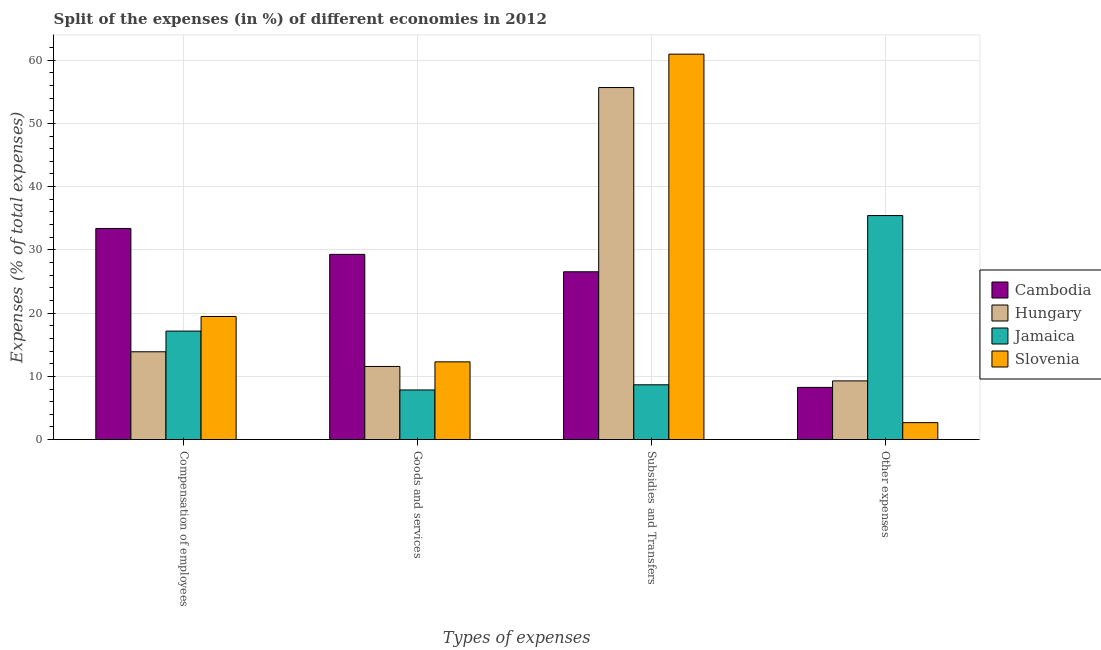How many different coloured bars are there?
Your answer should be very brief. 4. How many groups of bars are there?
Provide a short and direct response. 4. Are the number of bars per tick equal to the number of legend labels?
Your answer should be very brief. Yes. What is the label of the 3rd group of bars from the left?
Give a very brief answer. Subsidies and Transfers. What is the percentage of amount spent on compensation of employees in Slovenia?
Offer a terse response. 19.47. Across all countries, what is the maximum percentage of amount spent on other expenses?
Your response must be concise. 35.42. Across all countries, what is the minimum percentage of amount spent on goods and services?
Your answer should be compact. 7.85. In which country was the percentage of amount spent on subsidies maximum?
Your answer should be compact. Slovenia. In which country was the percentage of amount spent on other expenses minimum?
Keep it short and to the point. Slovenia. What is the total percentage of amount spent on other expenses in the graph?
Provide a short and direct response. 55.64. What is the difference between the percentage of amount spent on subsidies in Slovenia and that in Cambodia?
Your response must be concise. 34.41. What is the difference between the percentage of amount spent on goods and services in Hungary and the percentage of amount spent on other expenses in Cambodia?
Provide a succinct answer. 3.31. What is the average percentage of amount spent on compensation of employees per country?
Ensure brevity in your answer.  20.97. What is the difference between the percentage of amount spent on subsidies and percentage of amount spent on other expenses in Cambodia?
Make the answer very short. 18.28. In how many countries, is the percentage of amount spent on goods and services greater than 2 %?
Make the answer very short. 4. What is the ratio of the percentage of amount spent on goods and services in Jamaica to that in Cambodia?
Ensure brevity in your answer.  0.27. Is the percentage of amount spent on subsidies in Jamaica less than that in Cambodia?
Provide a succinct answer. Yes. Is the difference between the percentage of amount spent on goods and services in Cambodia and Slovenia greater than the difference between the percentage of amount spent on compensation of employees in Cambodia and Slovenia?
Offer a very short reply. Yes. What is the difference between the highest and the second highest percentage of amount spent on subsidies?
Offer a very short reply. 5.28. What is the difference between the highest and the lowest percentage of amount spent on other expenses?
Offer a very short reply. 32.74. In how many countries, is the percentage of amount spent on other expenses greater than the average percentage of amount spent on other expenses taken over all countries?
Give a very brief answer. 1. Is the sum of the percentage of amount spent on other expenses in Jamaica and Slovenia greater than the maximum percentage of amount spent on goods and services across all countries?
Your response must be concise. Yes. What does the 1st bar from the left in Goods and services represents?
Offer a terse response. Cambodia. What does the 2nd bar from the right in Compensation of employees represents?
Provide a succinct answer. Jamaica. How many bars are there?
Offer a terse response. 16. Are the values on the major ticks of Y-axis written in scientific E-notation?
Your answer should be compact. No. Does the graph contain any zero values?
Your answer should be very brief. No. Does the graph contain grids?
Offer a very short reply. Yes. How are the legend labels stacked?
Offer a very short reply. Vertical. What is the title of the graph?
Keep it short and to the point. Split of the expenses (in %) of different economies in 2012. What is the label or title of the X-axis?
Your answer should be very brief. Types of expenses. What is the label or title of the Y-axis?
Your answer should be very brief. Expenses (% of total expenses). What is the Expenses (% of total expenses) of Cambodia in Compensation of employees?
Your answer should be very brief. 33.38. What is the Expenses (% of total expenses) of Hungary in Compensation of employees?
Provide a short and direct response. 13.89. What is the Expenses (% of total expenses) of Jamaica in Compensation of employees?
Ensure brevity in your answer.  17.16. What is the Expenses (% of total expenses) in Slovenia in Compensation of employees?
Ensure brevity in your answer.  19.47. What is the Expenses (% of total expenses) of Cambodia in Goods and services?
Provide a succinct answer. 29.29. What is the Expenses (% of total expenses) in Hungary in Goods and services?
Provide a succinct answer. 11.57. What is the Expenses (% of total expenses) of Jamaica in Goods and services?
Make the answer very short. 7.85. What is the Expenses (% of total expenses) of Slovenia in Goods and services?
Offer a very short reply. 12.29. What is the Expenses (% of total expenses) in Cambodia in Subsidies and Transfers?
Ensure brevity in your answer.  26.54. What is the Expenses (% of total expenses) of Hungary in Subsidies and Transfers?
Make the answer very short. 55.66. What is the Expenses (% of total expenses) in Jamaica in Subsidies and Transfers?
Give a very brief answer. 8.67. What is the Expenses (% of total expenses) of Slovenia in Subsidies and Transfers?
Keep it short and to the point. 60.94. What is the Expenses (% of total expenses) in Cambodia in Other expenses?
Keep it short and to the point. 8.25. What is the Expenses (% of total expenses) in Hungary in Other expenses?
Offer a terse response. 9.28. What is the Expenses (% of total expenses) in Jamaica in Other expenses?
Ensure brevity in your answer.  35.42. What is the Expenses (% of total expenses) in Slovenia in Other expenses?
Your response must be concise. 2.68. Across all Types of expenses, what is the maximum Expenses (% of total expenses) of Cambodia?
Make the answer very short. 33.38. Across all Types of expenses, what is the maximum Expenses (% of total expenses) in Hungary?
Your answer should be very brief. 55.66. Across all Types of expenses, what is the maximum Expenses (% of total expenses) of Jamaica?
Your answer should be compact. 35.42. Across all Types of expenses, what is the maximum Expenses (% of total expenses) of Slovenia?
Provide a succinct answer. 60.94. Across all Types of expenses, what is the minimum Expenses (% of total expenses) in Cambodia?
Provide a succinct answer. 8.25. Across all Types of expenses, what is the minimum Expenses (% of total expenses) in Hungary?
Give a very brief answer. 9.28. Across all Types of expenses, what is the minimum Expenses (% of total expenses) in Jamaica?
Provide a short and direct response. 7.85. Across all Types of expenses, what is the minimum Expenses (% of total expenses) in Slovenia?
Give a very brief answer. 2.68. What is the total Expenses (% of total expenses) in Cambodia in the graph?
Make the answer very short. 97.46. What is the total Expenses (% of total expenses) in Hungary in the graph?
Keep it short and to the point. 90.4. What is the total Expenses (% of total expenses) of Jamaica in the graph?
Keep it short and to the point. 69.1. What is the total Expenses (% of total expenses) of Slovenia in the graph?
Ensure brevity in your answer.  95.38. What is the difference between the Expenses (% of total expenses) in Cambodia in Compensation of employees and that in Goods and services?
Provide a short and direct response. 4.1. What is the difference between the Expenses (% of total expenses) of Hungary in Compensation of employees and that in Goods and services?
Your response must be concise. 2.32. What is the difference between the Expenses (% of total expenses) in Jamaica in Compensation of employees and that in Goods and services?
Provide a short and direct response. 9.31. What is the difference between the Expenses (% of total expenses) of Slovenia in Compensation of employees and that in Goods and services?
Ensure brevity in your answer.  7.18. What is the difference between the Expenses (% of total expenses) in Cambodia in Compensation of employees and that in Subsidies and Transfers?
Provide a succinct answer. 6.85. What is the difference between the Expenses (% of total expenses) of Hungary in Compensation of employees and that in Subsidies and Transfers?
Give a very brief answer. -41.78. What is the difference between the Expenses (% of total expenses) in Jamaica in Compensation of employees and that in Subsidies and Transfers?
Provide a succinct answer. 8.49. What is the difference between the Expenses (% of total expenses) in Slovenia in Compensation of employees and that in Subsidies and Transfers?
Your response must be concise. -41.47. What is the difference between the Expenses (% of total expenses) of Cambodia in Compensation of employees and that in Other expenses?
Provide a succinct answer. 25.13. What is the difference between the Expenses (% of total expenses) in Hungary in Compensation of employees and that in Other expenses?
Give a very brief answer. 4.6. What is the difference between the Expenses (% of total expenses) of Jamaica in Compensation of employees and that in Other expenses?
Offer a terse response. -18.26. What is the difference between the Expenses (% of total expenses) of Slovenia in Compensation of employees and that in Other expenses?
Keep it short and to the point. 16.79. What is the difference between the Expenses (% of total expenses) in Cambodia in Goods and services and that in Subsidies and Transfers?
Offer a terse response. 2.75. What is the difference between the Expenses (% of total expenses) in Hungary in Goods and services and that in Subsidies and Transfers?
Your answer should be compact. -44.1. What is the difference between the Expenses (% of total expenses) of Jamaica in Goods and services and that in Subsidies and Transfers?
Make the answer very short. -0.82. What is the difference between the Expenses (% of total expenses) in Slovenia in Goods and services and that in Subsidies and Transfers?
Your answer should be compact. -48.65. What is the difference between the Expenses (% of total expenses) in Cambodia in Goods and services and that in Other expenses?
Your response must be concise. 21.03. What is the difference between the Expenses (% of total expenses) of Hungary in Goods and services and that in Other expenses?
Your response must be concise. 2.28. What is the difference between the Expenses (% of total expenses) of Jamaica in Goods and services and that in Other expenses?
Provide a succinct answer. -27.57. What is the difference between the Expenses (% of total expenses) in Slovenia in Goods and services and that in Other expenses?
Provide a short and direct response. 9.61. What is the difference between the Expenses (% of total expenses) in Cambodia in Subsidies and Transfers and that in Other expenses?
Offer a terse response. 18.28. What is the difference between the Expenses (% of total expenses) in Hungary in Subsidies and Transfers and that in Other expenses?
Provide a short and direct response. 46.38. What is the difference between the Expenses (% of total expenses) of Jamaica in Subsidies and Transfers and that in Other expenses?
Offer a very short reply. -26.75. What is the difference between the Expenses (% of total expenses) of Slovenia in Subsidies and Transfers and that in Other expenses?
Ensure brevity in your answer.  58.26. What is the difference between the Expenses (% of total expenses) in Cambodia in Compensation of employees and the Expenses (% of total expenses) in Hungary in Goods and services?
Provide a short and direct response. 21.82. What is the difference between the Expenses (% of total expenses) in Cambodia in Compensation of employees and the Expenses (% of total expenses) in Jamaica in Goods and services?
Give a very brief answer. 25.53. What is the difference between the Expenses (% of total expenses) in Cambodia in Compensation of employees and the Expenses (% of total expenses) in Slovenia in Goods and services?
Keep it short and to the point. 21.09. What is the difference between the Expenses (% of total expenses) of Hungary in Compensation of employees and the Expenses (% of total expenses) of Jamaica in Goods and services?
Your response must be concise. 6.04. What is the difference between the Expenses (% of total expenses) in Hungary in Compensation of employees and the Expenses (% of total expenses) in Slovenia in Goods and services?
Offer a terse response. 1.59. What is the difference between the Expenses (% of total expenses) of Jamaica in Compensation of employees and the Expenses (% of total expenses) of Slovenia in Goods and services?
Provide a short and direct response. 4.86. What is the difference between the Expenses (% of total expenses) in Cambodia in Compensation of employees and the Expenses (% of total expenses) in Hungary in Subsidies and Transfers?
Ensure brevity in your answer.  -22.28. What is the difference between the Expenses (% of total expenses) of Cambodia in Compensation of employees and the Expenses (% of total expenses) of Jamaica in Subsidies and Transfers?
Offer a very short reply. 24.72. What is the difference between the Expenses (% of total expenses) of Cambodia in Compensation of employees and the Expenses (% of total expenses) of Slovenia in Subsidies and Transfers?
Provide a succinct answer. -27.56. What is the difference between the Expenses (% of total expenses) in Hungary in Compensation of employees and the Expenses (% of total expenses) in Jamaica in Subsidies and Transfers?
Make the answer very short. 5.22. What is the difference between the Expenses (% of total expenses) in Hungary in Compensation of employees and the Expenses (% of total expenses) in Slovenia in Subsidies and Transfers?
Make the answer very short. -47.06. What is the difference between the Expenses (% of total expenses) in Jamaica in Compensation of employees and the Expenses (% of total expenses) in Slovenia in Subsidies and Transfers?
Your response must be concise. -43.79. What is the difference between the Expenses (% of total expenses) in Cambodia in Compensation of employees and the Expenses (% of total expenses) in Hungary in Other expenses?
Ensure brevity in your answer.  24.1. What is the difference between the Expenses (% of total expenses) in Cambodia in Compensation of employees and the Expenses (% of total expenses) in Jamaica in Other expenses?
Make the answer very short. -2.04. What is the difference between the Expenses (% of total expenses) of Cambodia in Compensation of employees and the Expenses (% of total expenses) of Slovenia in Other expenses?
Provide a succinct answer. 30.7. What is the difference between the Expenses (% of total expenses) in Hungary in Compensation of employees and the Expenses (% of total expenses) in Jamaica in Other expenses?
Keep it short and to the point. -21.54. What is the difference between the Expenses (% of total expenses) of Hungary in Compensation of employees and the Expenses (% of total expenses) of Slovenia in Other expenses?
Provide a succinct answer. 11.2. What is the difference between the Expenses (% of total expenses) of Jamaica in Compensation of employees and the Expenses (% of total expenses) of Slovenia in Other expenses?
Provide a short and direct response. 14.48. What is the difference between the Expenses (% of total expenses) in Cambodia in Goods and services and the Expenses (% of total expenses) in Hungary in Subsidies and Transfers?
Keep it short and to the point. -26.38. What is the difference between the Expenses (% of total expenses) in Cambodia in Goods and services and the Expenses (% of total expenses) in Jamaica in Subsidies and Transfers?
Make the answer very short. 20.62. What is the difference between the Expenses (% of total expenses) of Cambodia in Goods and services and the Expenses (% of total expenses) of Slovenia in Subsidies and Transfers?
Your response must be concise. -31.66. What is the difference between the Expenses (% of total expenses) of Hungary in Goods and services and the Expenses (% of total expenses) of Jamaica in Subsidies and Transfers?
Your response must be concise. 2.9. What is the difference between the Expenses (% of total expenses) in Hungary in Goods and services and the Expenses (% of total expenses) in Slovenia in Subsidies and Transfers?
Your answer should be compact. -49.37. What is the difference between the Expenses (% of total expenses) in Jamaica in Goods and services and the Expenses (% of total expenses) in Slovenia in Subsidies and Transfers?
Offer a terse response. -53.09. What is the difference between the Expenses (% of total expenses) in Cambodia in Goods and services and the Expenses (% of total expenses) in Hungary in Other expenses?
Your answer should be compact. 20. What is the difference between the Expenses (% of total expenses) in Cambodia in Goods and services and the Expenses (% of total expenses) in Jamaica in Other expenses?
Keep it short and to the point. -6.13. What is the difference between the Expenses (% of total expenses) in Cambodia in Goods and services and the Expenses (% of total expenses) in Slovenia in Other expenses?
Your response must be concise. 26.61. What is the difference between the Expenses (% of total expenses) of Hungary in Goods and services and the Expenses (% of total expenses) of Jamaica in Other expenses?
Offer a terse response. -23.85. What is the difference between the Expenses (% of total expenses) of Hungary in Goods and services and the Expenses (% of total expenses) of Slovenia in Other expenses?
Provide a short and direct response. 8.89. What is the difference between the Expenses (% of total expenses) of Jamaica in Goods and services and the Expenses (% of total expenses) of Slovenia in Other expenses?
Make the answer very short. 5.17. What is the difference between the Expenses (% of total expenses) of Cambodia in Subsidies and Transfers and the Expenses (% of total expenses) of Hungary in Other expenses?
Offer a terse response. 17.25. What is the difference between the Expenses (% of total expenses) of Cambodia in Subsidies and Transfers and the Expenses (% of total expenses) of Jamaica in Other expenses?
Offer a very short reply. -8.89. What is the difference between the Expenses (% of total expenses) of Cambodia in Subsidies and Transfers and the Expenses (% of total expenses) of Slovenia in Other expenses?
Your answer should be very brief. 23.85. What is the difference between the Expenses (% of total expenses) of Hungary in Subsidies and Transfers and the Expenses (% of total expenses) of Jamaica in Other expenses?
Your answer should be very brief. 20.24. What is the difference between the Expenses (% of total expenses) of Hungary in Subsidies and Transfers and the Expenses (% of total expenses) of Slovenia in Other expenses?
Make the answer very short. 52.98. What is the difference between the Expenses (% of total expenses) in Jamaica in Subsidies and Transfers and the Expenses (% of total expenses) in Slovenia in Other expenses?
Offer a terse response. 5.99. What is the average Expenses (% of total expenses) in Cambodia per Types of expenses?
Make the answer very short. 24.36. What is the average Expenses (% of total expenses) of Hungary per Types of expenses?
Your answer should be very brief. 22.6. What is the average Expenses (% of total expenses) in Jamaica per Types of expenses?
Make the answer very short. 17.27. What is the average Expenses (% of total expenses) in Slovenia per Types of expenses?
Your answer should be very brief. 23.85. What is the difference between the Expenses (% of total expenses) in Cambodia and Expenses (% of total expenses) in Hungary in Compensation of employees?
Offer a terse response. 19.5. What is the difference between the Expenses (% of total expenses) in Cambodia and Expenses (% of total expenses) in Jamaica in Compensation of employees?
Provide a short and direct response. 16.23. What is the difference between the Expenses (% of total expenses) of Cambodia and Expenses (% of total expenses) of Slovenia in Compensation of employees?
Your answer should be compact. 13.92. What is the difference between the Expenses (% of total expenses) of Hungary and Expenses (% of total expenses) of Jamaica in Compensation of employees?
Offer a terse response. -3.27. What is the difference between the Expenses (% of total expenses) of Hungary and Expenses (% of total expenses) of Slovenia in Compensation of employees?
Ensure brevity in your answer.  -5.58. What is the difference between the Expenses (% of total expenses) in Jamaica and Expenses (% of total expenses) in Slovenia in Compensation of employees?
Keep it short and to the point. -2.31. What is the difference between the Expenses (% of total expenses) of Cambodia and Expenses (% of total expenses) of Hungary in Goods and services?
Give a very brief answer. 17.72. What is the difference between the Expenses (% of total expenses) of Cambodia and Expenses (% of total expenses) of Jamaica in Goods and services?
Offer a terse response. 21.44. What is the difference between the Expenses (% of total expenses) in Cambodia and Expenses (% of total expenses) in Slovenia in Goods and services?
Make the answer very short. 16.99. What is the difference between the Expenses (% of total expenses) in Hungary and Expenses (% of total expenses) in Jamaica in Goods and services?
Offer a terse response. 3.72. What is the difference between the Expenses (% of total expenses) of Hungary and Expenses (% of total expenses) of Slovenia in Goods and services?
Offer a terse response. -0.72. What is the difference between the Expenses (% of total expenses) of Jamaica and Expenses (% of total expenses) of Slovenia in Goods and services?
Your response must be concise. -4.44. What is the difference between the Expenses (% of total expenses) in Cambodia and Expenses (% of total expenses) in Hungary in Subsidies and Transfers?
Keep it short and to the point. -29.13. What is the difference between the Expenses (% of total expenses) in Cambodia and Expenses (% of total expenses) in Jamaica in Subsidies and Transfers?
Provide a short and direct response. 17.87. What is the difference between the Expenses (% of total expenses) in Cambodia and Expenses (% of total expenses) in Slovenia in Subsidies and Transfers?
Offer a very short reply. -34.41. What is the difference between the Expenses (% of total expenses) of Hungary and Expenses (% of total expenses) of Jamaica in Subsidies and Transfers?
Your answer should be very brief. 47. What is the difference between the Expenses (% of total expenses) in Hungary and Expenses (% of total expenses) in Slovenia in Subsidies and Transfers?
Give a very brief answer. -5.28. What is the difference between the Expenses (% of total expenses) in Jamaica and Expenses (% of total expenses) in Slovenia in Subsidies and Transfers?
Offer a terse response. -52.28. What is the difference between the Expenses (% of total expenses) of Cambodia and Expenses (% of total expenses) of Hungary in Other expenses?
Offer a very short reply. -1.03. What is the difference between the Expenses (% of total expenses) of Cambodia and Expenses (% of total expenses) of Jamaica in Other expenses?
Your answer should be compact. -27.17. What is the difference between the Expenses (% of total expenses) in Cambodia and Expenses (% of total expenses) in Slovenia in Other expenses?
Offer a terse response. 5.57. What is the difference between the Expenses (% of total expenses) in Hungary and Expenses (% of total expenses) in Jamaica in Other expenses?
Make the answer very short. -26.14. What is the difference between the Expenses (% of total expenses) in Hungary and Expenses (% of total expenses) in Slovenia in Other expenses?
Ensure brevity in your answer.  6.6. What is the difference between the Expenses (% of total expenses) of Jamaica and Expenses (% of total expenses) of Slovenia in Other expenses?
Your answer should be very brief. 32.74. What is the ratio of the Expenses (% of total expenses) of Cambodia in Compensation of employees to that in Goods and services?
Make the answer very short. 1.14. What is the ratio of the Expenses (% of total expenses) in Hungary in Compensation of employees to that in Goods and services?
Offer a very short reply. 1.2. What is the ratio of the Expenses (% of total expenses) in Jamaica in Compensation of employees to that in Goods and services?
Offer a terse response. 2.19. What is the ratio of the Expenses (% of total expenses) of Slovenia in Compensation of employees to that in Goods and services?
Your response must be concise. 1.58. What is the ratio of the Expenses (% of total expenses) in Cambodia in Compensation of employees to that in Subsidies and Transfers?
Give a very brief answer. 1.26. What is the ratio of the Expenses (% of total expenses) in Hungary in Compensation of employees to that in Subsidies and Transfers?
Provide a succinct answer. 0.25. What is the ratio of the Expenses (% of total expenses) of Jamaica in Compensation of employees to that in Subsidies and Transfers?
Provide a succinct answer. 1.98. What is the ratio of the Expenses (% of total expenses) in Slovenia in Compensation of employees to that in Subsidies and Transfers?
Your answer should be compact. 0.32. What is the ratio of the Expenses (% of total expenses) of Cambodia in Compensation of employees to that in Other expenses?
Give a very brief answer. 4.04. What is the ratio of the Expenses (% of total expenses) in Hungary in Compensation of employees to that in Other expenses?
Provide a succinct answer. 1.5. What is the ratio of the Expenses (% of total expenses) of Jamaica in Compensation of employees to that in Other expenses?
Provide a short and direct response. 0.48. What is the ratio of the Expenses (% of total expenses) of Slovenia in Compensation of employees to that in Other expenses?
Make the answer very short. 7.26. What is the ratio of the Expenses (% of total expenses) of Cambodia in Goods and services to that in Subsidies and Transfers?
Give a very brief answer. 1.1. What is the ratio of the Expenses (% of total expenses) in Hungary in Goods and services to that in Subsidies and Transfers?
Your answer should be compact. 0.21. What is the ratio of the Expenses (% of total expenses) of Jamaica in Goods and services to that in Subsidies and Transfers?
Offer a terse response. 0.91. What is the ratio of the Expenses (% of total expenses) in Slovenia in Goods and services to that in Subsidies and Transfers?
Your response must be concise. 0.2. What is the ratio of the Expenses (% of total expenses) of Cambodia in Goods and services to that in Other expenses?
Provide a succinct answer. 3.55. What is the ratio of the Expenses (% of total expenses) in Hungary in Goods and services to that in Other expenses?
Provide a short and direct response. 1.25. What is the ratio of the Expenses (% of total expenses) of Jamaica in Goods and services to that in Other expenses?
Keep it short and to the point. 0.22. What is the ratio of the Expenses (% of total expenses) in Slovenia in Goods and services to that in Other expenses?
Offer a very short reply. 4.58. What is the ratio of the Expenses (% of total expenses) of Cambodia in Subsidies and Transfers to that in Other expenses?
Your answer should be very brief. 3.22. What is the ratio of the Expenses (% of total expenses) in Hungary in Subsidies and Transfers to that in Other expenses?
Provide a short and direct response. 6. What is the ratio of the Expenses (% of total expenses) of Jamaica in Subsidies and Transfers to that in Other expenses?
Provide a succinct answer. 0.24. What is the ratio of the Expenses (% of total expenses) of Slovenia in Subsidies and Transfers to that in Other expenses?
Your response must be concise. 22.73. What is the difference between the highest and the second highest Expenses (% of total expenses) of Cambodia?
Give a very brief answer. 4.1. What is the difference between the highest and the second highest Expenses (% of total expenses) in Hungary?
Make the answer very short. 41.78. What is the difference between the highest and the second highest Expenses (% of total expenses) of Jamaica?
Your response must be concise. 18.26. What is the difference between the highest and the second highest Expenses (% of total expenses) of Slovenia?
Your answer should be compact. 41.47. What is the difference between the highest and the lowest Expenses (% of total expenses) of Cambodia?
Give a very brief answer. 25.13. What is the difference between the highest and the lowest Expenses (% of total expenses) in Hungary?
Ensure brevity in your answer.  46.38. What is the difference between the highest and the lowest Expenses (% of total expenses) in Jamaica?
Make the answer very short. 27.57. What is the difference between the highest and the lowest Expenses (% of total expenses) of Slovenia?
Offer a terse response. 58.26. 